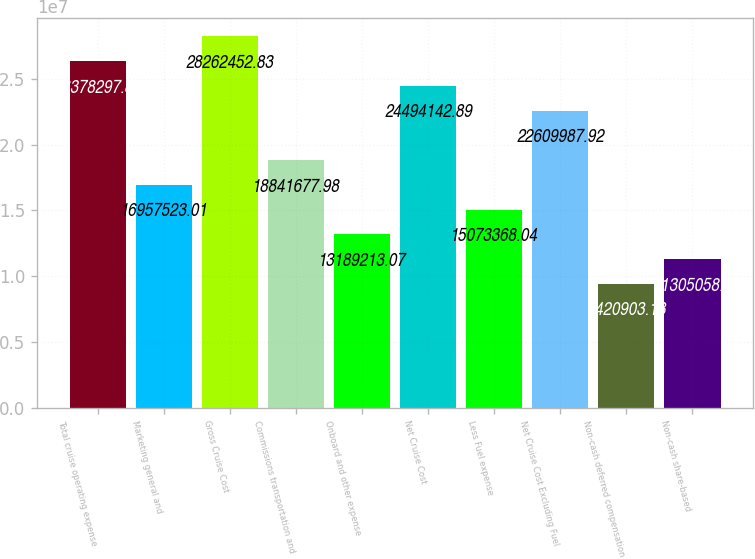Convert chart to OTSL. <chart><loc_0><loc_0><loc_500><loc_500><bar_chart><fcel>Total cruise operating expense<fcel>Marketing general and<fcel>Gross Cruise Cost<fcel>Commissions transportation and<fcel>Onboard and other expense<fcel>Net Cruise Cost<fcel>Less Fuel expense<fcel>Net Cruise Cost Excluding Fuel<fcel>Non-cash deferred compensation<fcel>Non-cash share-based<nl><fcel>2.63783e+07<fcel>1.69575e+07<fcel>2.82625e+07<fcel>1.88417e+07<fcel>1.31892e+07<fcel>2.44941e+07<fcel>1.50734e+07<fcel>2.261e+07<fcel>9.4209e+06<fcel>1.13051e+07<nl></chart> 